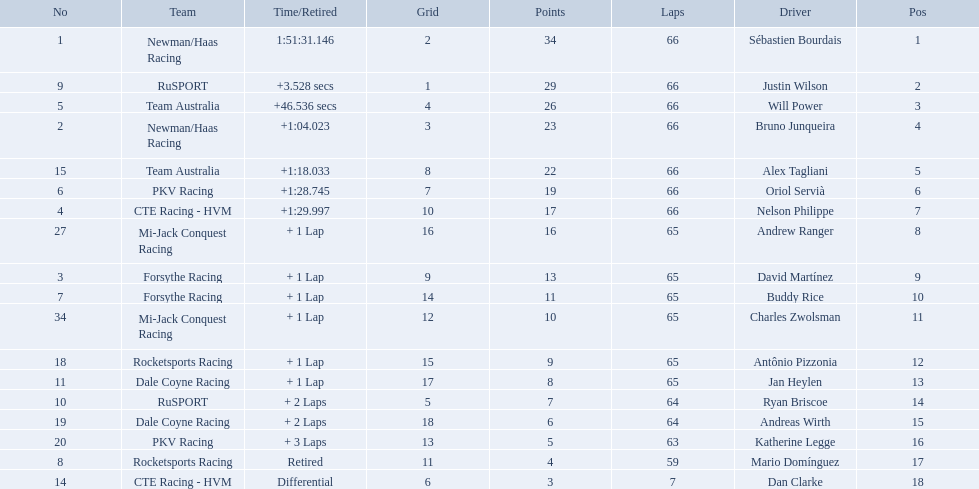What are the names of the drivers who were in position 14 through position 18? Ryan Briscoe, Andreas Wirth, Katherine Legge, Mario Domínguez, Dan Clarke. Of these , which ones didn't finish due to retired or differential? Mario Domínguez, Dan Clarke. Which one of the previous drivers retired? Mario Domínguez. Which of the drivers in question 2 had a differential? Dan Clarke. What was the highest amount of points scored in the 2006 gran premio? 34. Who scored 34 points? Sébastien Bourdais. Who are the drivers? Sébastien Bourdais, Justin Wilson, Will Power, Bruno Junqueira, Alex Tagliani, Oriol Servià, Nelson Philippe, Andrew Ranger, David Martínez, Buddy Rice, Charles Zwolsman, Antônio Pizzonia, Jan Heylen, Ryan Briscoe, Andreas Wirth, Katherine Legge, Mario Domínguez, Dan Clarke. What are their numbers? 1, 9, 5, 2, 15, 6, 4, 27, 3, 7, 34, 18, 11, 10, 19, 20, 8, 14. What are their positions? 1, 2, 3, 4, 5, 6, 7, 8, 9, 10, 11, 12, 13, 14, 15, 16, 17, 18. Which driver has the same number and position? Sébastien Bourdais. 